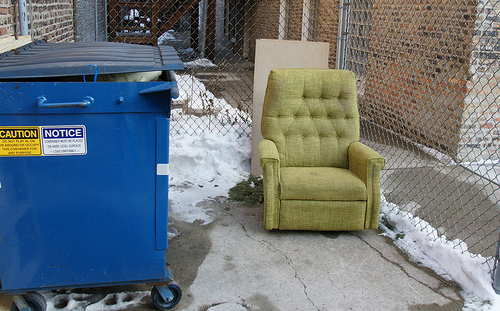<image>
Is the chair to the right of the garbage? Yes. From this viewpoint, the chair is positioned to the right side relative to the garbage. 